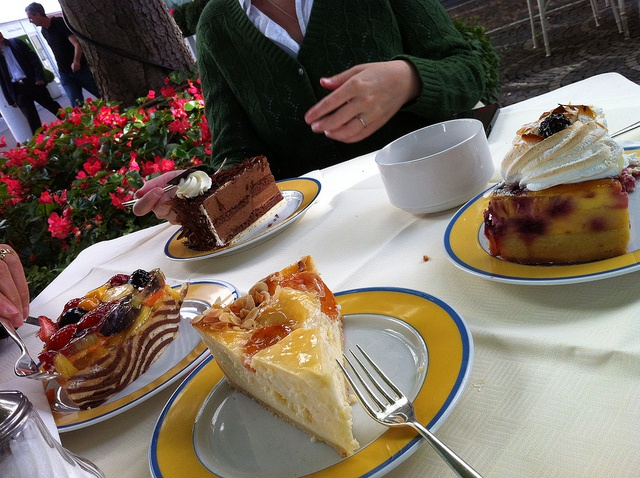Describe the objects in this image and their specific colors. I can see dining table in white, lightgray, darkgray, and gray tones, people in white, black, brown, and maroon tones, cake in white, maroon, darkgray, olive, and black tones, cake in white, tan, and brown tones, and cake in white, maroon, black, and brown tones in this image. 